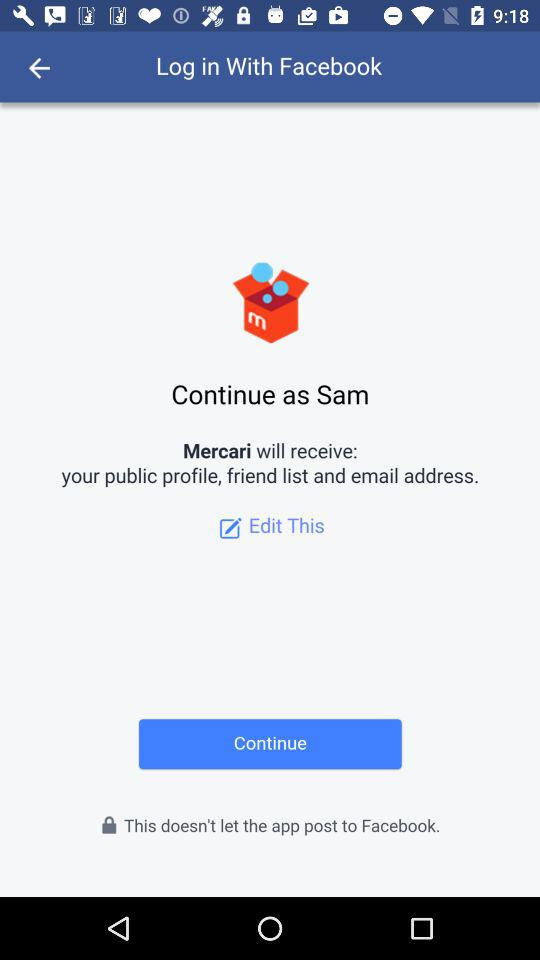Through what application can logging in be done? Logging in can be done through "Facebook". 